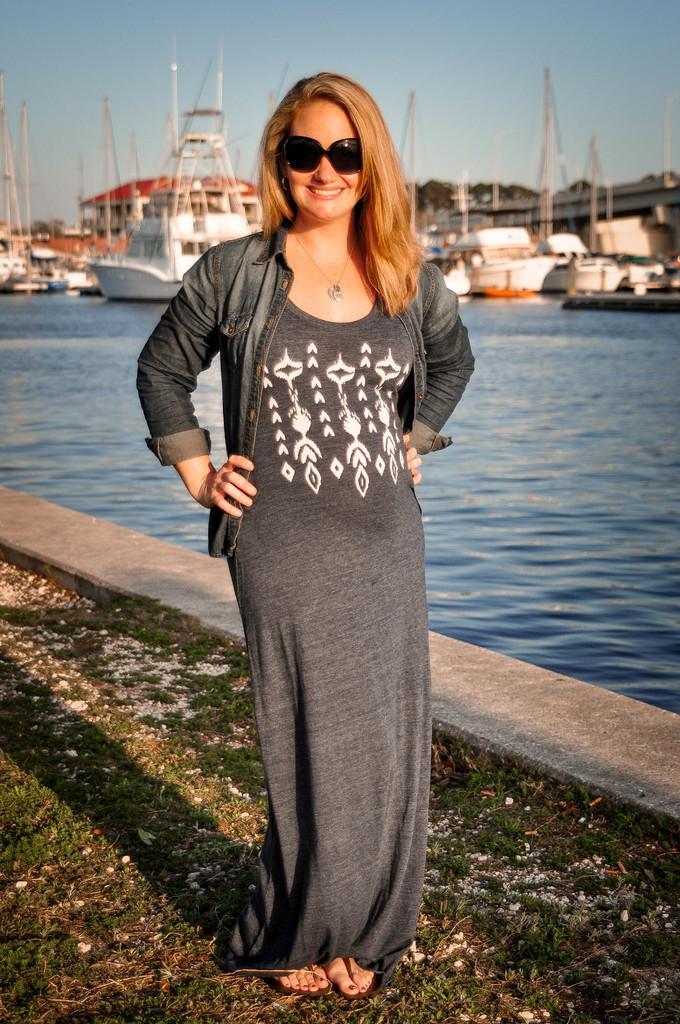In one or two sentences, can you explain what this image depicts? In this image there is a woman standing on the ground by wearing the spectacles. Behind her there is water. In the water there are so many boats and ships. At the bottom there is grass. At the top there is the sky. 